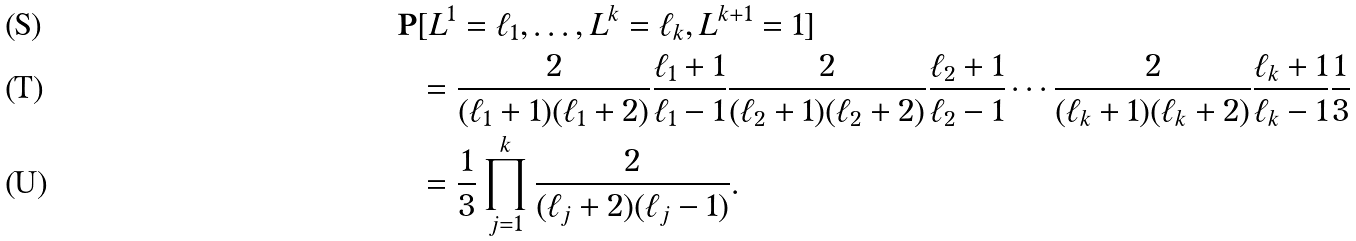<formula> <loc_0><loc_0><loc_500><loc_500>\mathbf P & [ L ^ { 1 } = \ell _ { 1 } , \dots , L ^ { k } = \ell _ { k } , L ^ { k + 1 } = 1 ] \\ & = \frac { 2 } { ( \ell _ { 1 } + 1 ) ( \ell _ { 1 } + 2 ) } \frac { \ell _ { 1 } + 1 } { \ell _ { 1 } - 1 } \frac { 2 } { ( \ell _ { 2 } + 1 ) ( \ell _ { 2 } + 2 ) } \frac { \ell _ { 2 } + 1 } { \ell _ { 2 } - 1 } \cdots \frac { 2 } { ( \ell _ { k } + 1 ) ( \ell _ { k } + 2 ) } \frac { \ell _ { k } + 1 } { \ell _ { k } - 1 } \frac { 1 } { 3 } \\ & = \frac { 1 } { 3 } \prod _ { j = 1 } ^ { k } \frac { 2 } { ( \ell _ { j } + 2 ) ( \ell _ { j } - 1 ) } .</formula> 